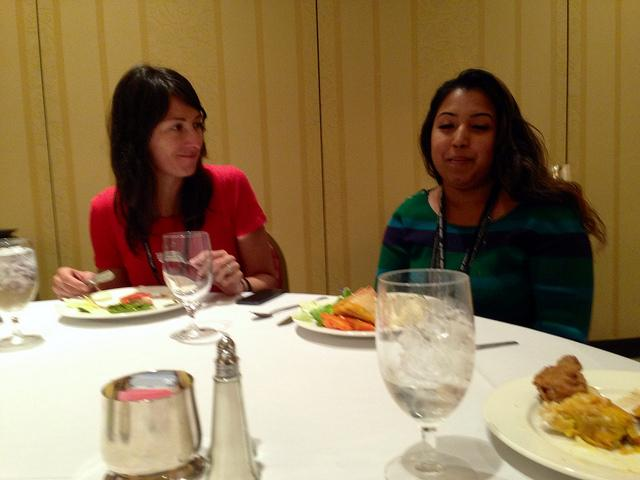What part of the meal is being eaten? Please explain your reasoning. entree. There is meat and cooked items on the plate. 